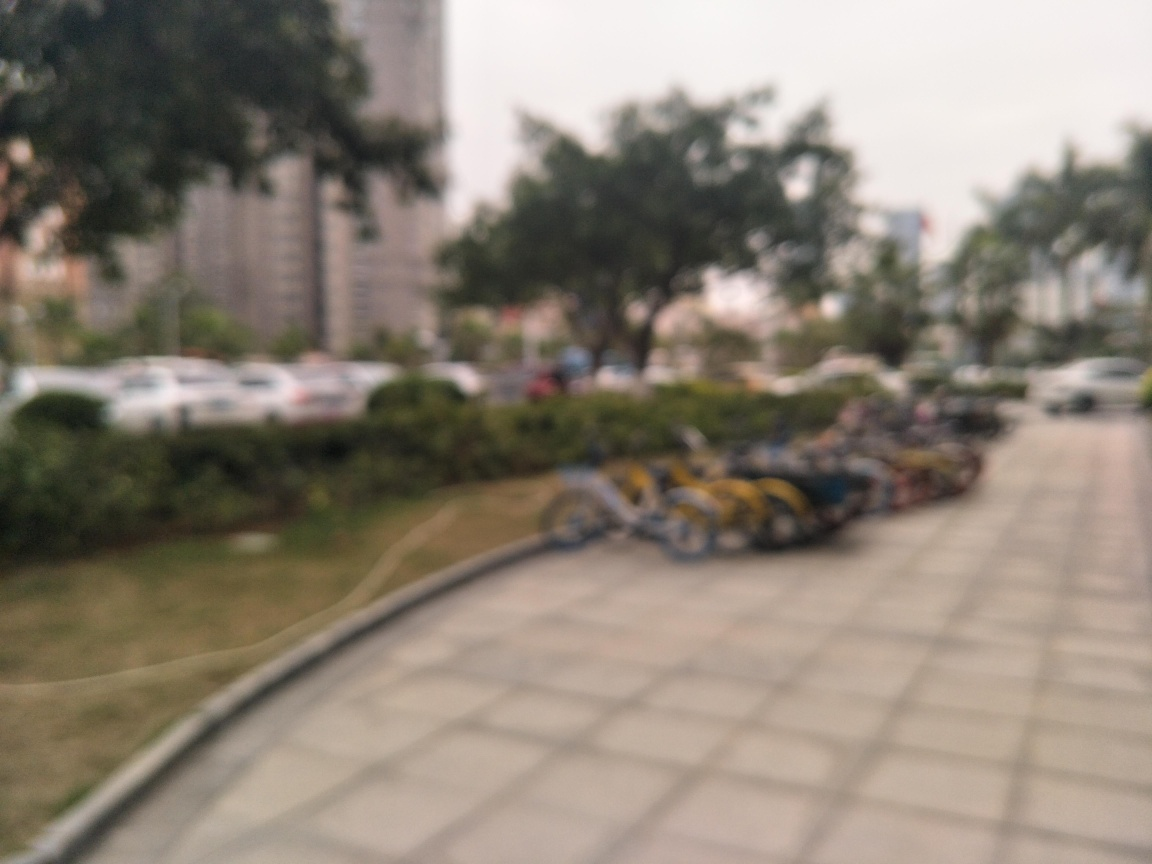What are the possible objects in the foreground? Based on the shapes and colors, they seem to resemble a line of parked bicycles, indicated by the repeating patterns that suggest bike frames and wheels, even though the details are obscure due to the blur. 